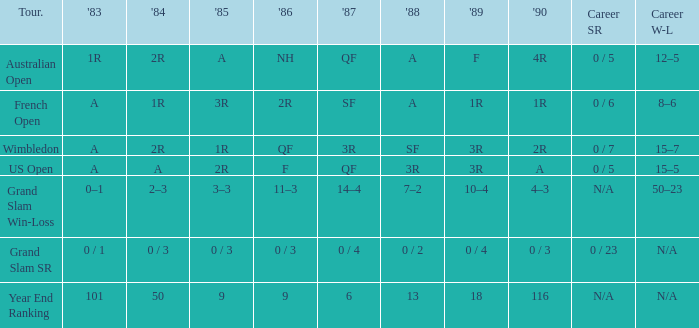What were the outcomes in 1985 with a 1986 nh of and a career sr of 0/5? A. 